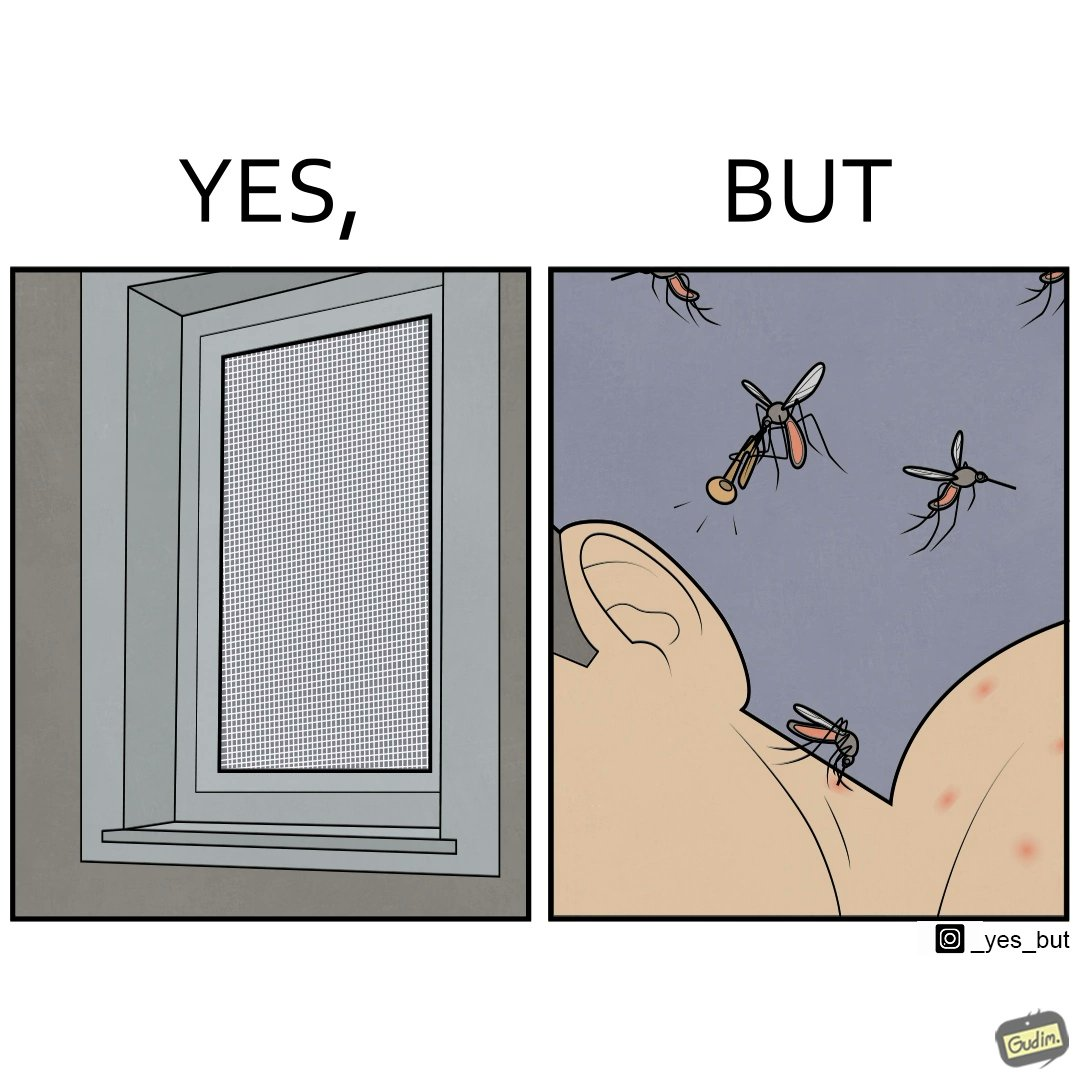Describe the content of this image. The images are funny since it shows how even though we try to keep mosquitoes away from us using methods like mosquito nets, they still find a way to ruin our sleep by biting and making noise 